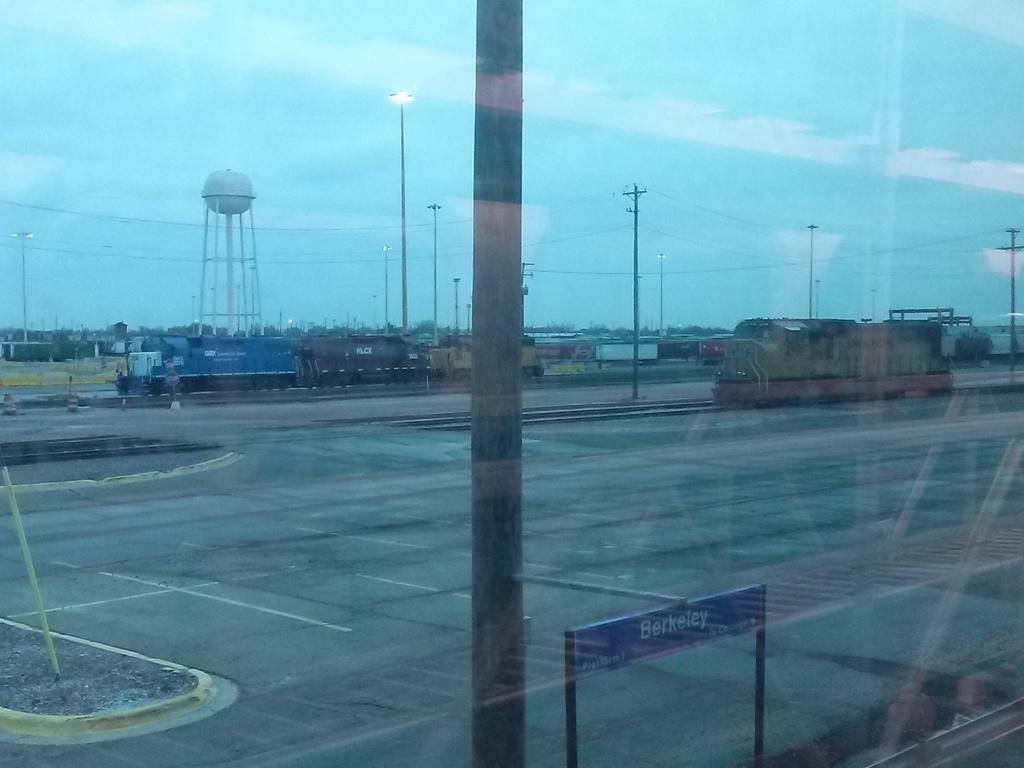What place is listed on the blue banner / sign?
Ensure brevity in your answer.  Berkeley. 